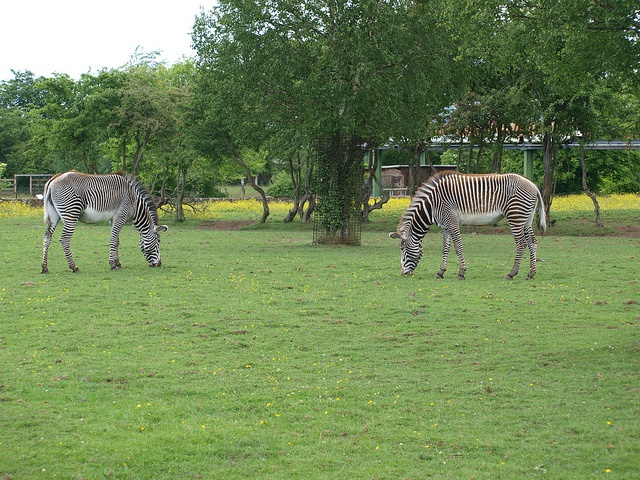Describe the objects in this image and their specific colors. I can see zebra in white, gray, darkgray, black, and lightgray tones, zebra in white, gray, darkgray, black, and lightgray tones, and train in white, gray, black, and darkgreen tones in this image. 